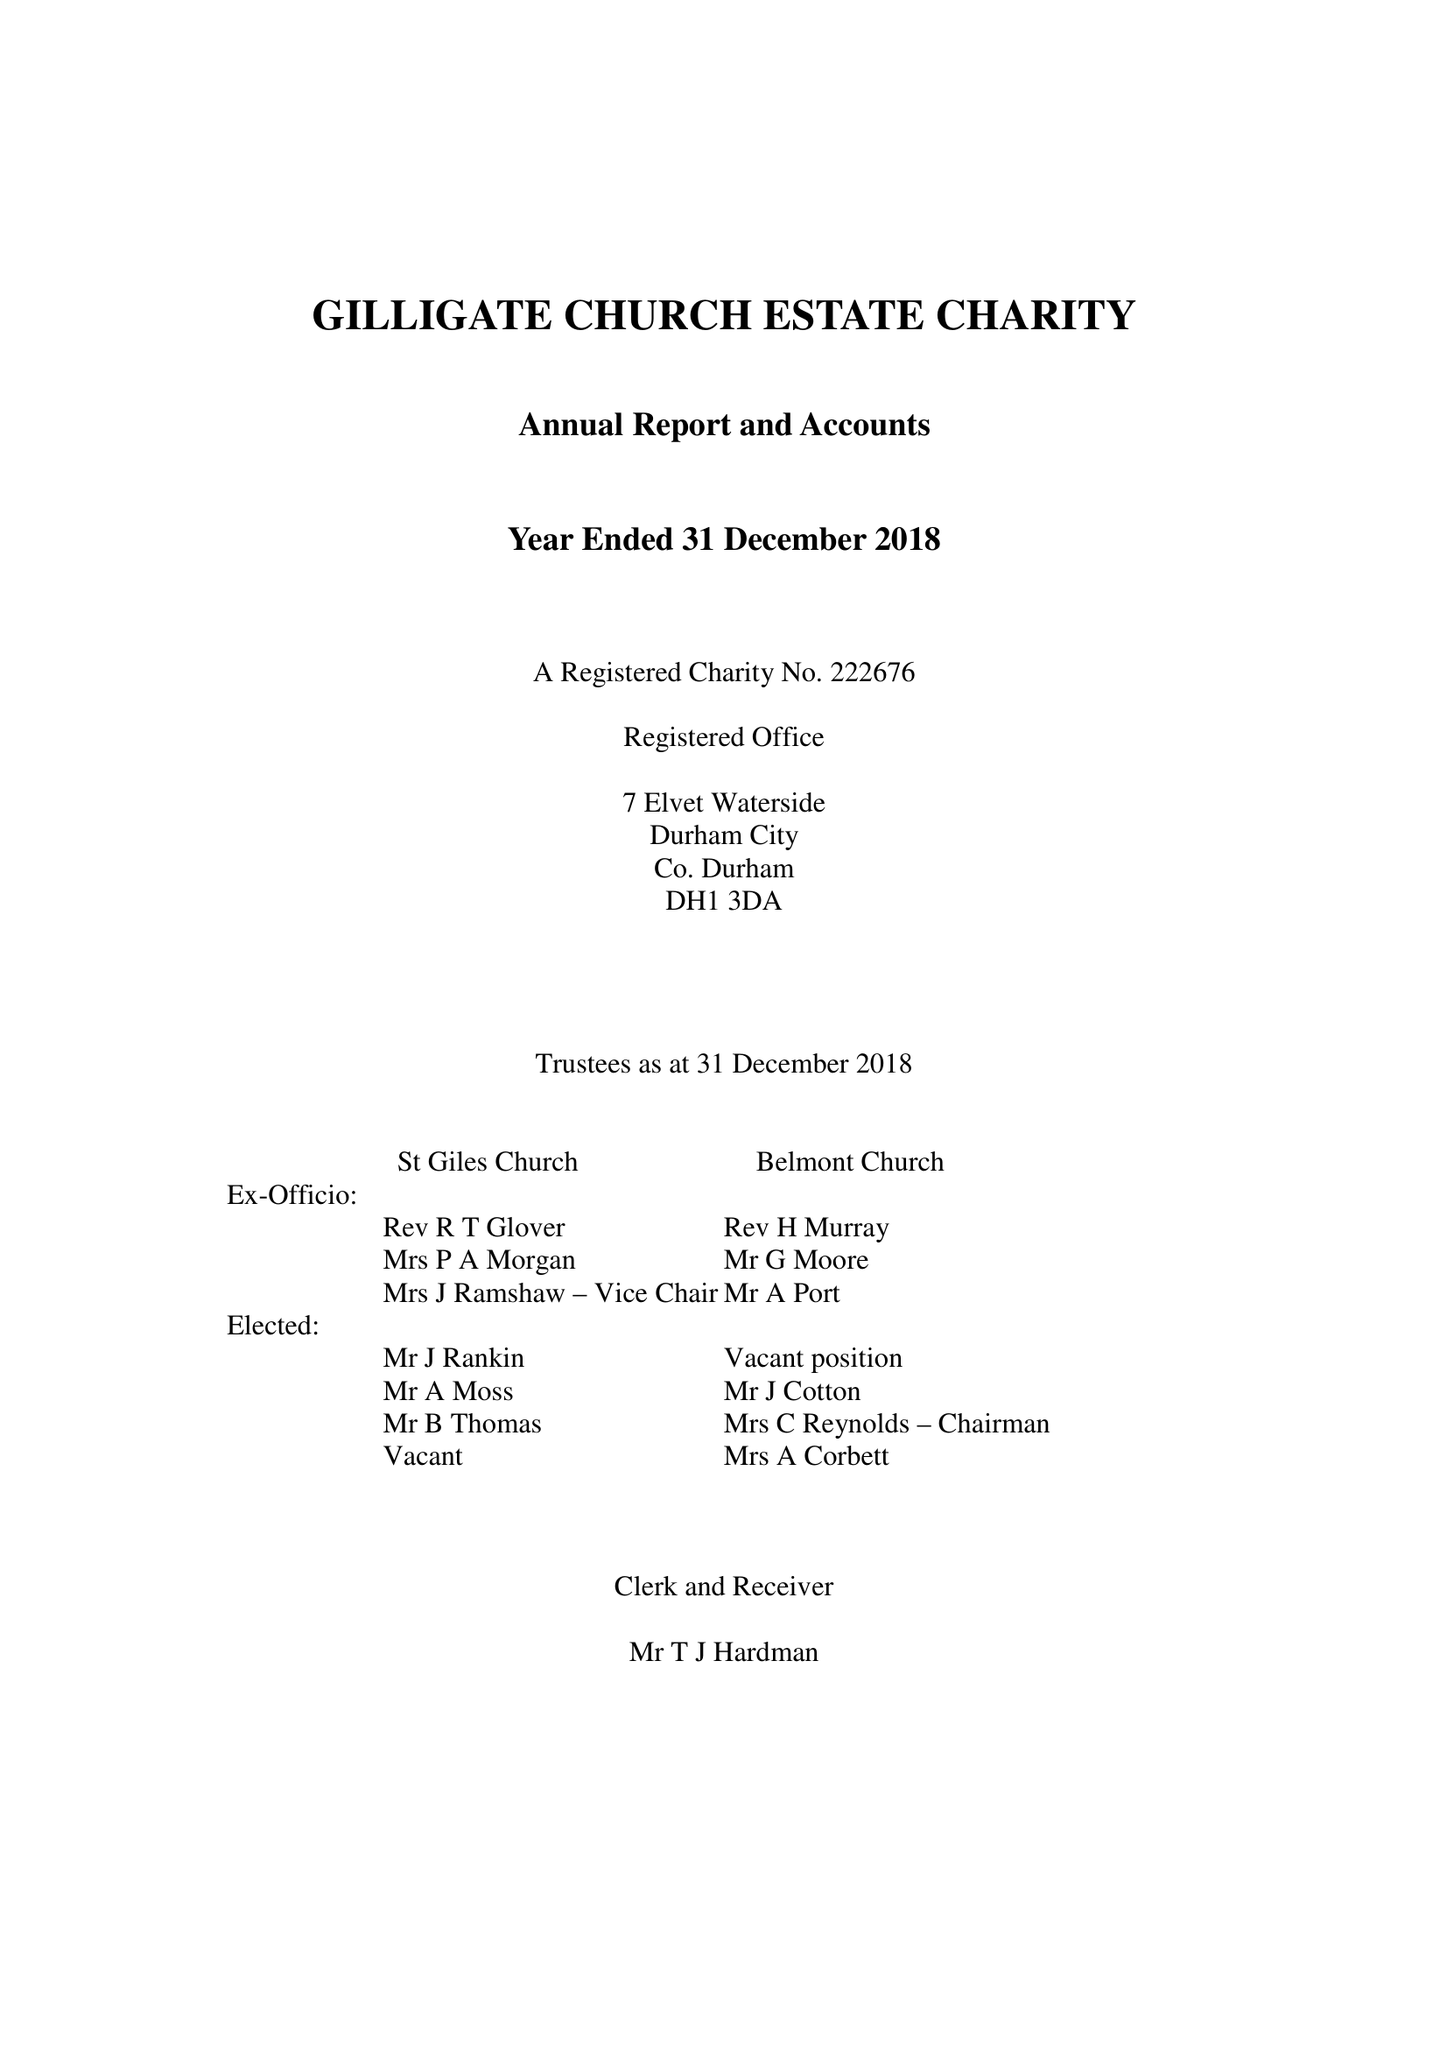What is the value for the charity_name?
Answer the question using a single word or phrase. Gilligate Church Estate Charity 